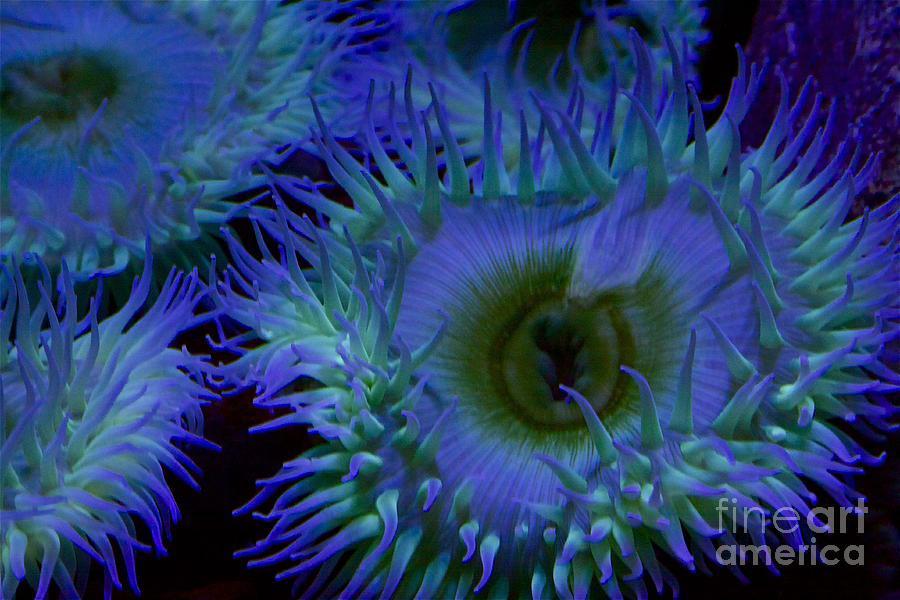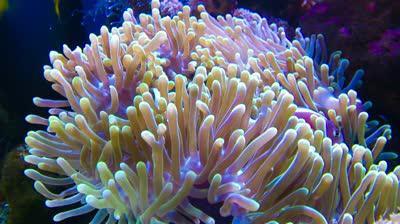The first image is the image on the left, the second image is the image on the right. For the images shown, is this caption "There are red stones on the sea floor." true? Answer yes or no. No. 